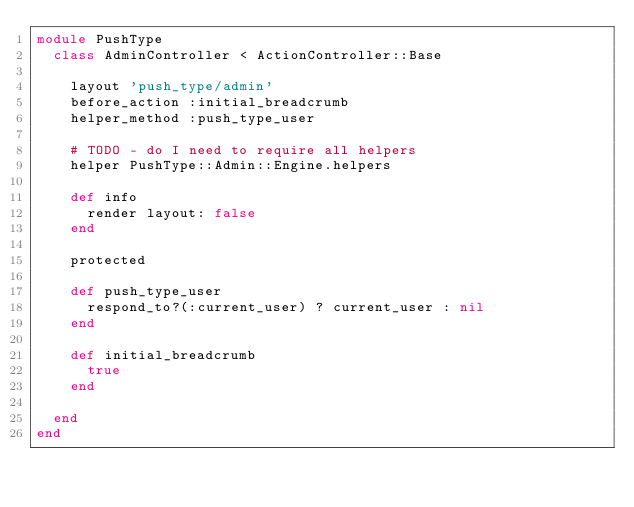Convert code to text. <code><loc_0><loc_0><loc_500><loc_500><_Ruby_>module PushType
  class AdminController < ActionController::Base

    layout 'push_type/admin'
    before_action :initial_breadcrumb
    helper_method :push_type_user

    # TODO - do I need to require all helpers
    helper PushType::Admin::Engine.helpers

    def info
      render layout: false
    end

    protected

    def push_type_user
      respond_to?(:current_user) ? current_user : nil
    end

    def initial_breadcrumb
      true
    end
    
  end
end
</code> 